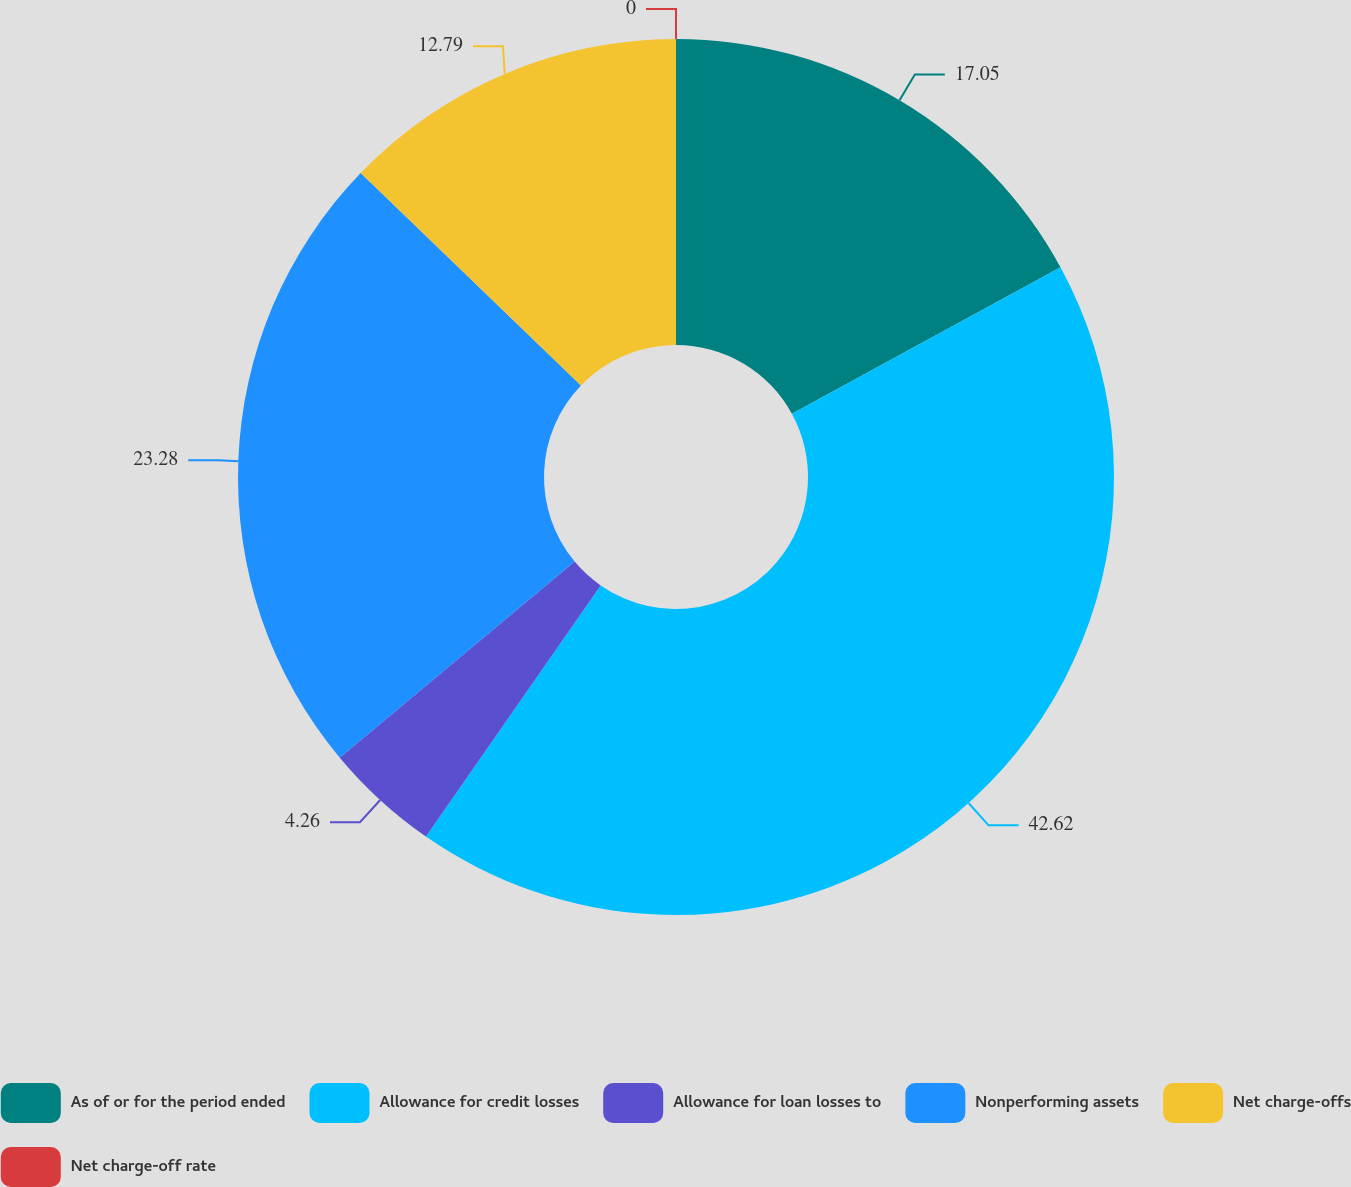Convert chart. <chart><loc_0><loc_0><loc_500><loc_500><pie_chart><fcel>As of or for the period ended<fcel>Allowance for credit losses<fcel>Allowance for loan losses to<fcel>Nonperforming assets<fcel>Net charge-offs<fcel>Net charge-off rate<nl><fcel>17.05%<fcel>42.62%<fcel>4.26%<fcel>23.28%<fcel>12.79%<fcel>0.0%<nl></chart> 